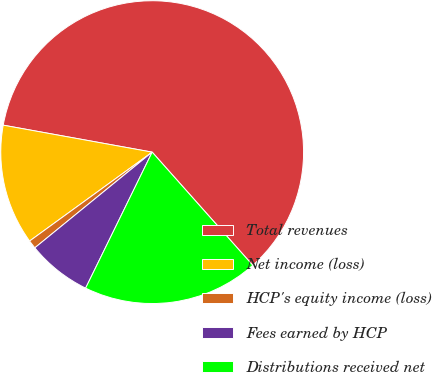Convert chart. <chart><loc_0><loc_0><loc_500><loc_500><pie_chart><fcel>Total revenues<fcel>Net income (loss)<fcel>HCP's equity income (loss)<fcel>Fees earned by HCP<fcel>Distributions received net<nl><fcel>60.59%<fcel>12.84%<fcel>0.9%<fcel>6.87%<fcel>18.81%<nl></chart> 